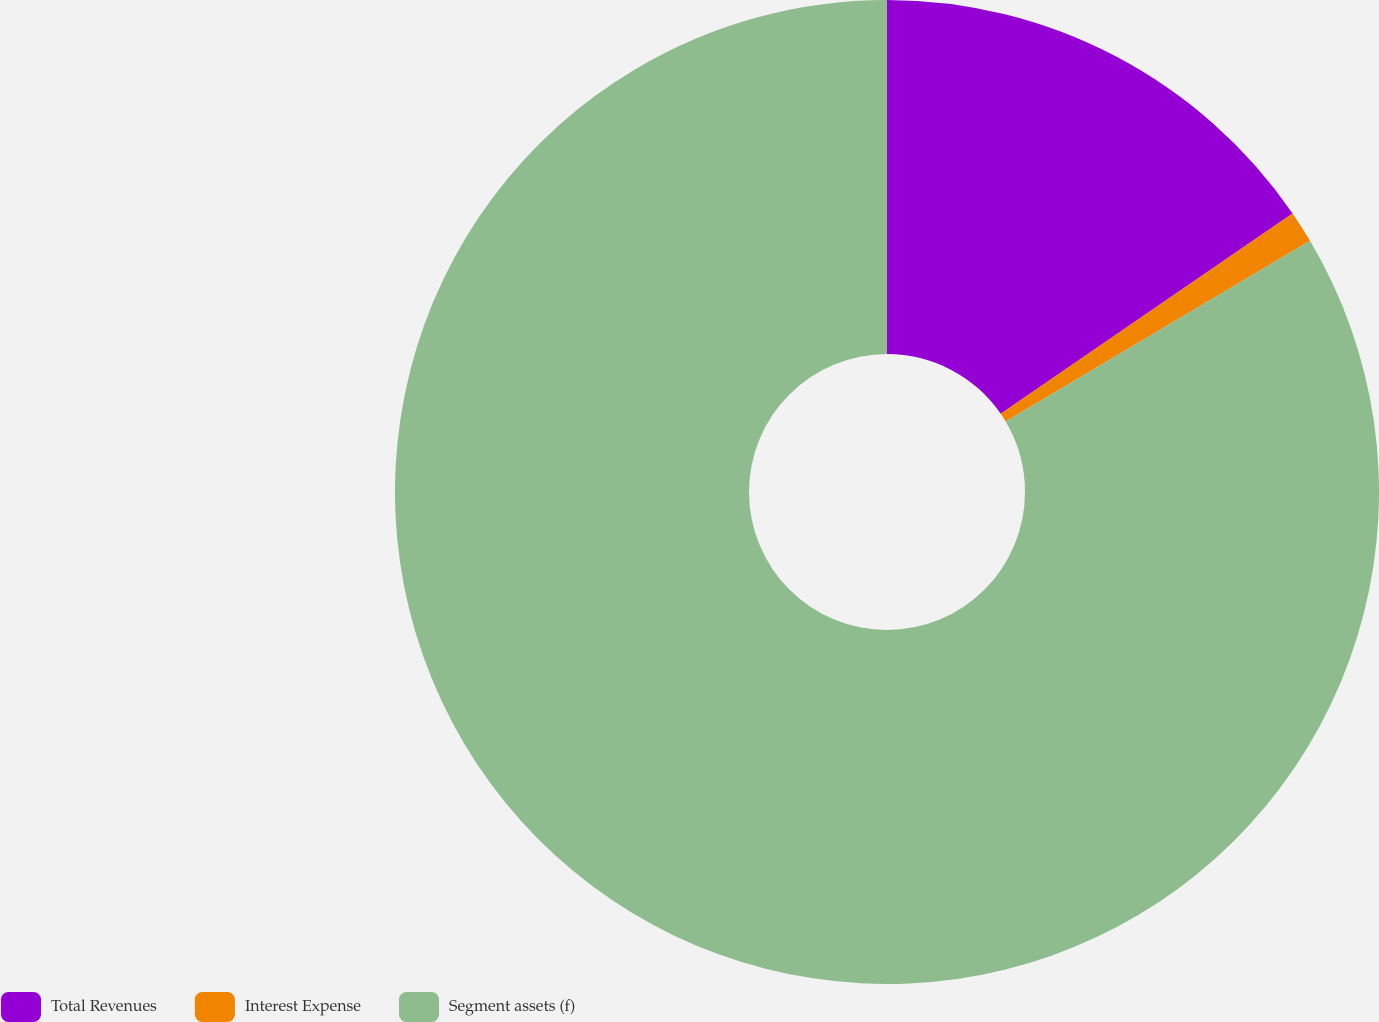<chart> <loc_0><loc_0><loc_500><loc_500><pie_chart><fcel>Total Revenues<fcel>Interest Expense<fcel>Segment assets (f)<nl><fcel>15.42%<fcel>1.05%<fcel>83.52%<nl></chart> 